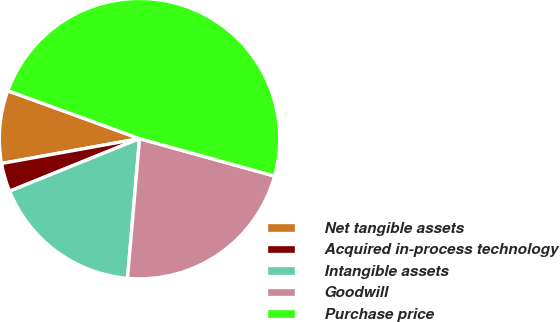Convert chart to OTSL. <chart><loc_0><loc_0><loc_500><loc_500><pie_chart><fcel>Net tangible assets<fcel>Acquired in-process technology<fcel>Intangible assets<fcel>Goodwill<fcel>Purchase price<nl><fcel>8.39%<fcel>3.28%<fcel>17.51%<fcel>22.06%<fcel>48.75%<nl></chart> 